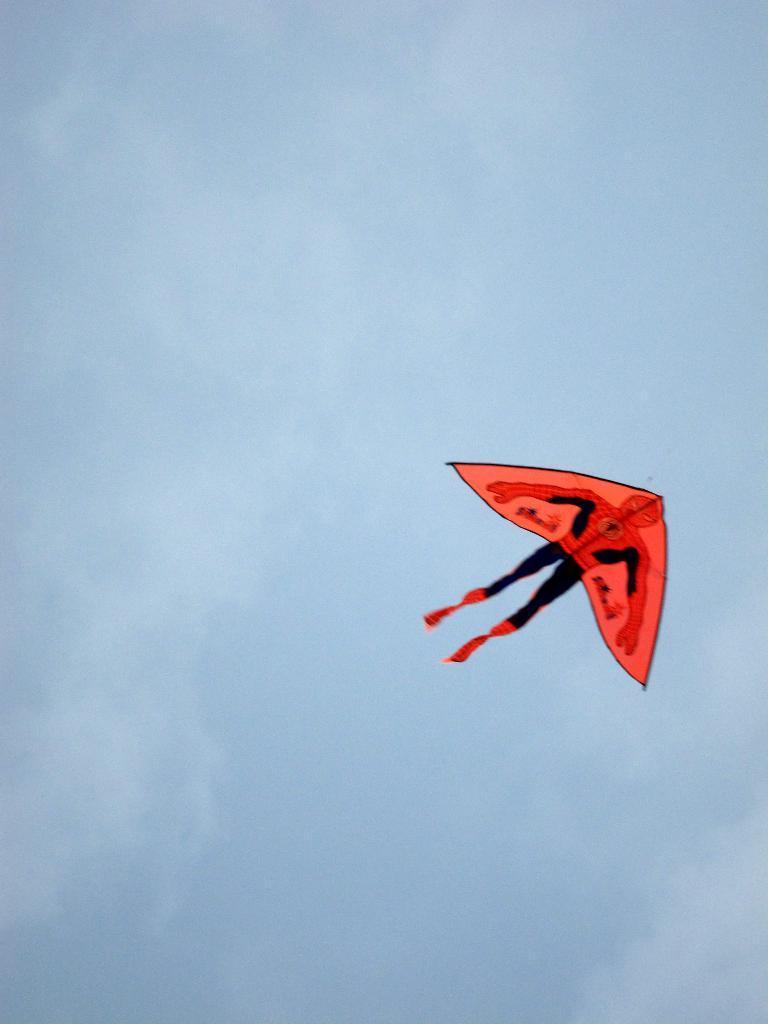Describe this image in one or two sentences. Here we can see a kite flying in the sky and we can see clouds also. 